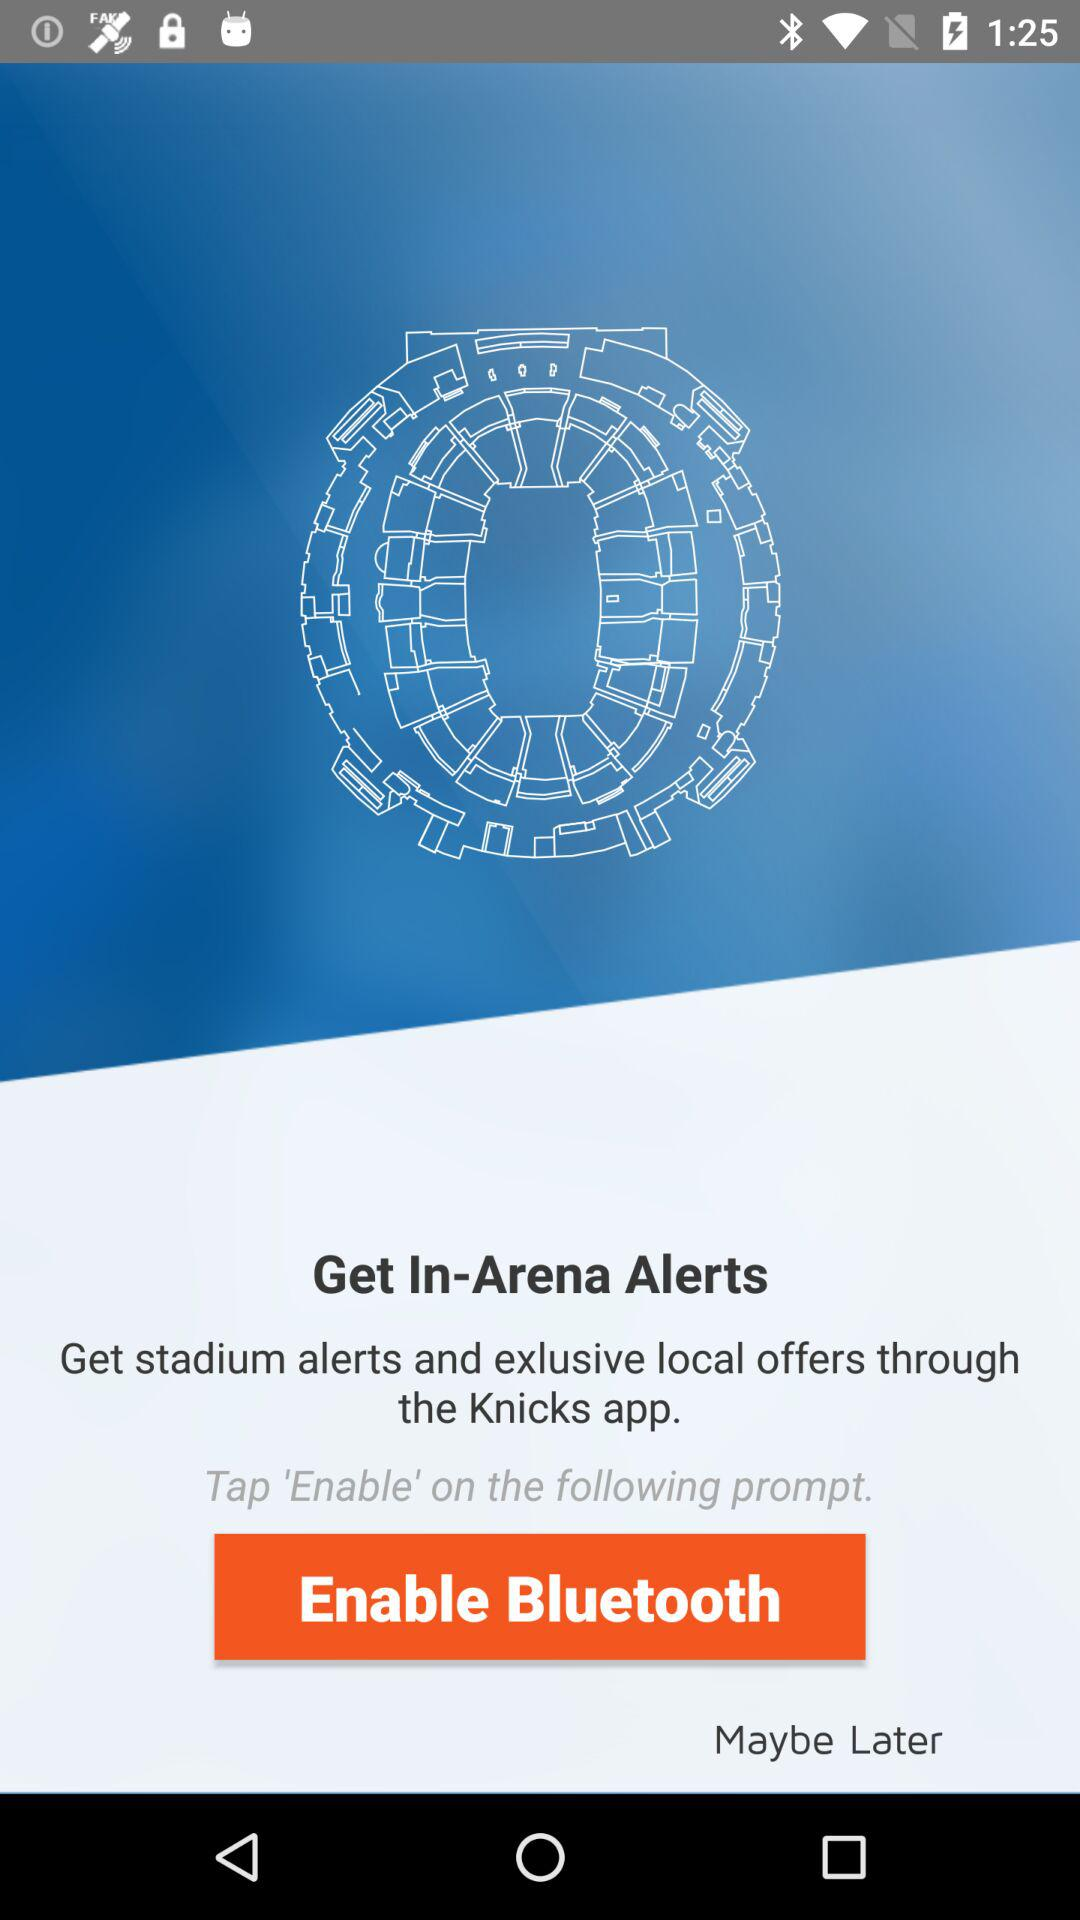What is the app name? The app name is "Knicks". 